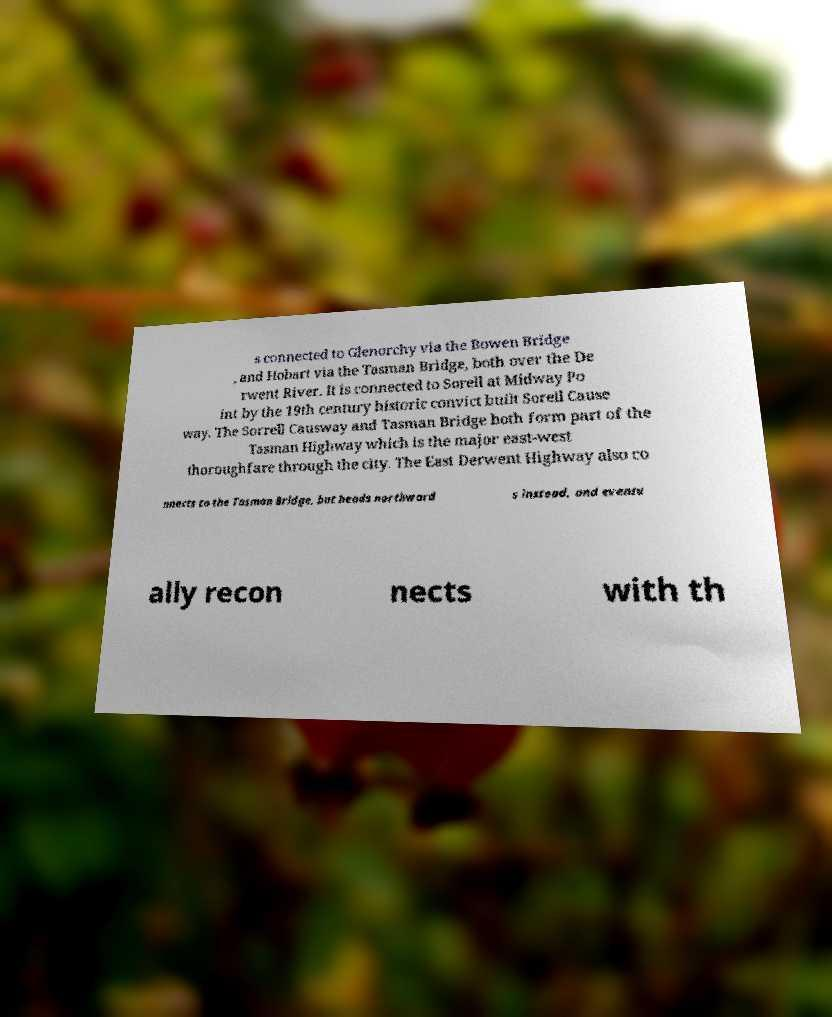Please identify and transcribe the text found in this image. s connected to Glenorchy via the Bowen Bridge , and Hobart via the Tasman Bridge, both over the De rwent River. It is connected to Sorell at Midway Po int by the 19th century historic convict built Sorell Cause way. The Sorrell Causway and Tasman Bridge both form part of the Tasman Highway which is the major east-west thoroughfare through the city. The East Derwent Highway also co nnects to the Tasman Bridge, but heads northward s instead, and eventu ally recon nects with th 